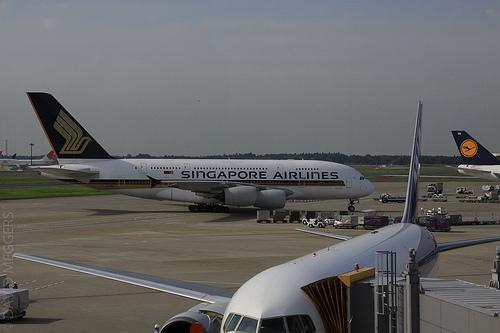Question: where is this scene?
Choices:
A. In the terminal.
B. At the train station.
C. At the bus station.
D. At the airport.
Answer with the letter. Answer: D Question: why is there darkness?
Choices:
A. Daytime.
B. Rain pouring.
C. Cloudy dust.
D. Overcast.
Answer with the letter. Answer: D Question: who is present?
Choices:
A. A man.
B. A dog.
C. A woman.
D. Nobody.
Answer with the letter. Answer: D Question: how is the photo?
Choices:
A. Dirty.
B. Clear.
C. Washed out.
D. Dark.
Answer with the letter. Answer: B 